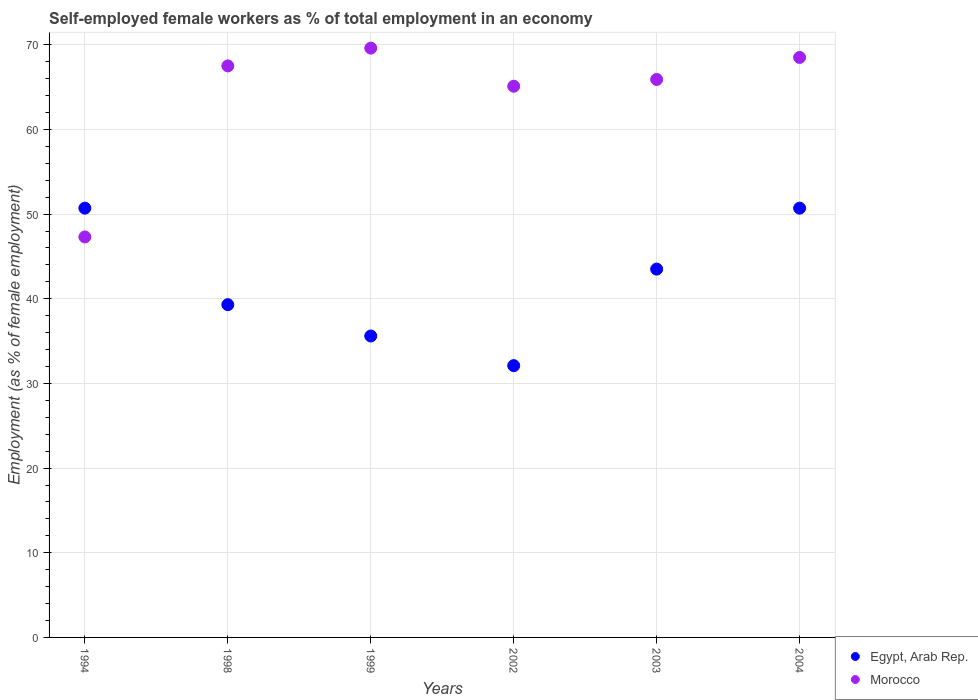How many different coloured dotlines are there?
Give a very brief answer. 2. What is the percentage of self-employed female workers in Morocco in 1999?
Give a very brief answer. 69.6. Across all years, what is the maximum percentage of self-employed female workers in Morocco?
Keep it short and to the point. 69.6. Across all years, what is the minimum percentage of self-employed female workers in Egypt, Arab Rep.?
Provide a succinct answer. 32.1. In which year was the percentage of self-employed female workers in Egypt, Arab Rep. maximum?
Your response must be concise. 1994. What is the total percentage of self-employed female workers in Morocco in the graph?
Provide a short and direct response. 383.9. What is the difference between the percentage of self-employed female workers in Egypt, Arab Rep. in 2002 and that in 2004?
Give a very brief answer. -18.6. What is the difference between the percentage of self-employed female workers in Egypt, Arab Rep. in 2004 and the percentage of self-employed female workers in Morocco in 1999?
Provide a short and direct response. -18.9. What is the average percentage of self-employed female workers in Egypt, Arab Rep. per year?
Offer a terse response. 41.98. In the year 2002, what is the difference between the percentage of self-employed female workers in Morocco and percentage of self-employed female workers in Egypt, Arab Rep.?
Provide a short and direct response. 33. What is the ratio of the percentage of self-employed female workers in Morocco in 1998 to that in 2004?
Your answer should be very brief. 0.99. Is the percentage of self-employed female workers in Egypt, Arab Rep. in 1994 less than that in 2003?
Your answer should be very brief. No. What is the difference between the highest and the second highest percentage of self-employed female workers in Egypt, Arab Rep.?
Give a very brief answer. 0. What is the difference between the highest and the lowest percentage of self-employed female workers in Morocco?
Provide a short and direct response. 22.3. How many dotlines are there?
Keep it short and to the point. 2. How many years are there in the graph?
Make the answer very short. 6. What is the difference between two consecutive major ticks on the Y-axis?
Give a very brief answer. 10. Are the values on the major ticks of Y-axis written in scientific E-notation?
Your answer should be compact. No. Where does the legend appear in the graph?
Offer a terse response. Bottom right. What is the title of the graph?
Your answer should be very brief. Self-employed female workers as % of total employment in an economy. Does "Grenada" appear as one of the legend labels in the graph?
Provide a short and direct response. No. What is the label or title of the Y-axis?
Offer a very short reply. Employment (as % of female employment). What is the Employment (as % of female employment) in Egypt, Arab Rep. in 1994?
Your answer should be compact. 50.7. What is the Employment (as % of female employment) of Morocco in 1994?
Provide a short and direct response. 47.3. What is the Employment (as % of female employment) of Egypt, Arab Rep. in 1998?
Provide a short and direct response. 39.3. What is the Employment (as % of female employment) of Morocco in 1998?
Provide a short and direct response. 67.5. What is the Employment (as % of female employment) in Egypt, Arab Rep. in 1999?
Give a very brief answer. 35.6. What is the Employment (as % of female employment) of Morocco in 1999?
Your answer should be very brief. 69.6. What is the Employment (as % of female employment) in Egypt, Arab Rep. in 2002?
Make the answer very short. 32.1. What is the Employment (as % of female employment) of Morocco in 2002?
Your answer should be compact. 65.1. What is the Employment (as % of female employment) of Egypt, Arab Rep. in 2003?
Offer a terse response. 43.5. What is the Employment (as % of female employment) in Morocco in 2003?
Make the answer very short. 65.9. What is the Employment (as % of female employment) of Egypt, Arab Rep. in 2004?
Give a very brief answer. 50.7. What is the Employment (as % of female employment) of Morocco in 2004?
Your answer should be compact. 68.5. Across all years, what is the maximum Employment (as % of female employment) in Egypt, Arab Rep.?
Give a very brief answer. 50.7. Across all years, what is the maximum Employment (as % of female employment) of Morocco?
Provide a succinct answer. 69.6. Across all years, what is the minimum Employment (as % of female employment) in Egypt, Arab Rep.?
Your answer should be compact. 32.1. Across all years, what is the minimum Employment (as % of female employment) of Morocco?
Offer a terse response. 47.3. What is the total Employment (as % of female employment) of Egypt, Arab Rep. in the graph?
Your answer should be compact. 251.9. What is the total Employment (as % of female employment) of Morocco in the graph?
Your answer should be compact. 383.9. What is the difference between the Employment (as % of female employment) of Egypt, Arab Rep. in 1994 and that in 1998?
Your answer should be compact. 11.4. What is the difference between the Employment (as % of female employment) of Morocco in 1994 and that in 1998?
Ensure brevity in your answer.  -20.2. What is the difference between the Employment (as % of female employment) in Egypt, Arab Rep. in 1994 and that in 1999?
Keep it short and to the point. 15.1. What is the difference between the Employment (as % of female employment) of Morocco in 1994 and that in 1999?
Provide a short and direct response. -22.3. What is the difference between the Employment (as % of female employment) of Morocco in 1994 and that in 2002?
Provide a succinct answer. -17.8. What is the difference between the Employment (as % of female employment) of Morocco in 1994 and that in 2003?
Your response must be concise. -18.6. What is the difference between the Employment (as % of female employment) of Egypt, Arab Rep. in 1994 and that in 2004?
Your response must be concise. 0. What is the difference between the Employment (as % of female employment) in Morocco in 1994 and that in 2004?
Provide a succinct answer. -21.2. What is the difference between the Employment (as % of female employment) in Egypt, Arab Rep. in 1998 and that in 1999?
Your answer should be very brief. 3.7. What is the difference between the Employment (as % of female employment) in Morocco in 1998 and that in 2002?
Your answer should be compact. 2.4. What is the difference between the Employment (as % of female employment) in Morocco in 1998 and that in 2003?
Make the answer very short. 1.6. What is the difference between the Employment (as % of female employment) in Egypt, Arab Rep. in 1999 and that in 2002?
Your answer should be very brief. 3.5. What is the difference between the Employment (as % of female employment) of Egypt, Arab Rep. in 1999 and that in 2004?
Offer a very short reply. -15.1. What is the difference between the Employment (as % of female employment) of Morocco in 1999 and that in 2004?
Give a very brief answer. 1.1. What is the difference between the Employment (as % of female employment) in Egypt, Arab Rep. in 2002 and that in 2003?
Your response must be concise. -11.4. What is the difference between the Employment (as % of female employment) in Morocco in 2002 and that in 2003?
Give a very brief answer. -0.8. What is the difference between the Employment (as % of female employment) in Egypt, Arab Rep. in 2002 and that in 2004?
Keep it short and to the point. -18.6. What is the difference between the Employment (as % of female employment) of Egypt, Arab Rep. in 1994 and the Employment (as % of female employment) of Morocco in 1998?
Ensure brevity in your answer.  -16.8. What is the difference between the Employment (as % of female employment) in Egypt, Arab Rep. in 1994 and the Employment (as % of female employment) in Morocco in 1999?
Provide a succinct answer. -18.9. What is the difference between the Employment (as % of female employment) of Egypt, Arab Rep. in 1994 and the Employment (as % of female employment) of Morocco in 2002?
Your answer should be very brief. -14.4. What is the difference between the Employment (as % of female employment) of Egypt, Arab Rep. in 1994 and the Employment (as % of female employment) of Morocco in 2003?
Your response must be concise. -15.2. What is the difference between the Employment (as % of female employment) of Egypt, Arab Rep. in 1994 and the Employment (as % of female employment) of Morocco in 2004?
Keep it short and to the point. -17.8. What is the difference between the Employment (as % of female employment) of Egypt, Arab Rep. in 1998 and the Employment (as % of female employment) of Morocco in 1999?
Provide a succinct answer. -30.3. What is the difference between the Employment (as % of female employment) in Egypt, Arab Rep. in 1998 and the Employment (as % of female employment) in Morocco in 2002?
Provide a succinct answer. -25.8. What is the difference between the Employment (as % of female employment) in Egypt, Arab Rep. in 1998 and the Employment (as % of female employment) in Morocco in 2003?
Make the answer very short. -26.6. What is the difference between the Employment (as % of female employment) in Egypt, Arab Rep. in 1998 and the Employment (as % of female employment) in Morocco in 2004?
Provide a short and direct response. -29.2. What is the difference between the Employment (as % of female employment) in Egypt, Arab Rep. in 1999 and the Employment (as % of female employment) in Morocco in 2002?
Provide a succinct answer. -29.5. What is the difference between the Employment (as % of female employment) of Egypt, Arab Rep. in 1999 and the Employment (as % of female employment) of Morocco in 2003?
Give a very brief answer. -30.3. What is the difference between the Employment (as % of female employment) of Egypt, Arab Rep. in 1999 and the Employment (as % of female employment) of Morocco in 2004?
Give a very brief answer. -32.9. What is the difference between the Employment (as % of female employment) of Egypt, Arab Rep. in 2002 and the Employment (as % of female employment) of Morocco in 2003?
Your response must be concise. -33.8. What is the difference between the Employment (as % of female employment) in Egypt, Arab Rep. in 2002 and the Employment (as % of female employment) in Morocco in 2004?
Give a very brief answer. -36.4. What is the difference between the Employment (as % of female employment) in Egypt, Arab Rep. in 2003 and the Employment (as % of female employment) in Morocco in 2004?
Your response must be concise. -25. What is the average Employment (as % of female employment) in Egypt, Arab Rep. per year?
Provide a succinct answer. 41.98. What is the average Employment (as % of female employment) of Morocco per year?
Offer a terse response. 63.98. In the year 1994, what is the difference between the Employment (as % of female employment) of Egypt, Arab Rep. and Employment (as % of female employment) of Morocco?
Provide a succinct answer. 3.4. In the year 1998, what is the difference between the Employment (as % of female employment) of Egypt, Arab Rep. and Employment (as % of female employment) of Morocco?
Ensure brevity in your answer.  -28.2. In the year 1999, what is the difference between the Employment (as % of female employment) of Egypt, Arab Rep. and Employment (as % of female employment) of Morocco?
Your answer should be very brief. -34. In the year 2002, what is the difference between the Employment (as % of female employment) of Egypt, Arab Rep. and Employment (as % of female employment) of Morocco?
Keep it short and to the point. -33. In the year 2003, what is the difference between the Employment (as % of female employment) in Egypt, Arab Rep. and Employment (as % of female employment) in Morocco?
Your answer should be compact. -22.4. In the year 2004, what is the difference between the Employment (as % of female employment) of Egypt, Arab Rep. and Employment (as % of female employment) of Morocco?
Offer a terse response. -17.8. What is the ratio of the Employment (as % of female employment) in Egypt, Arab Rep. in 1994 to that in 1998?
Your response must be concise. 1.29. What is the ratio of the Employment (as % of female employment) of Morocco in 1994 to that in 1998?
Ensure brevity in your answer.  0.7. What is the ratio of the Employment (as % of female employment) in Egypt, Arab Rep. in 1994 to that in 1999?
Make the answer very short. 1.42. What is the ratio of the Employment (as % of female employment) in Morocco in 1994 to that in 1999?
Provide a succinct answer. 0.68. What is the ratio of the Employment (as % of female employment) of Egypt, Arab Rep. in 1994 to that in 2002?
Your response must be concise. 1.58. What is the ratio of the Employment (as % of female employment) of Morocco in 1994 to that in 2002?
Provide a short and direct response. 0.73. What is the ratio of the Employment (as % of female employment) of Egypt, Arab Rep. in 1994 to that in 2003?
Offer a very short reply. 1.17. What is the ratio of the Employment (as % of female employment) of Morocco in 1994 to that in 2003?
Ensure brevity in your answer.  0.72. What is the ratio of the Employment (as % of female employment) in Morocco in 1994 to that in 2004?
Ensure brevity in your answer.  0.69. What is the ratio of the Employment (as % of female employment) of Egypt, Arab Rep. in 1998 to that in 1999?
Make the answer very short. 1.1. What is the ratio of the Employment (as % of female employment) in Morocco in 1998 to that in 1999?
Provide a short and direct response. 0.97. What is the ratio of the Employment (as % of female employment) of Egypt, Arab Rep. in 1998 to that in 2002?
Your answer should be compact. 1.22. What is the ratio of the Employment (as % of female employment) of Morocco in 1998 to that in 2002?
Give a very brief answer. 1.04. What is the ratio of the Employment (as % of female employment) in Egypt, Arab Rep. in 1998 to that in 2003?
Your response must be concise. 0.9. What is the ratio of the Employment (as % of female employment) of Morocco in 1998 to that in 2003?
Keep it short and to the point. 1.02. What is the ratio of the Employment (as % of female employment) of Egypt, Arab Rep. in 1998 to that in 2004?
Give a very brief answer. 0.78. What is the ratio of the Employment (as % of female employment) of Morocco in 1998 to that in 2004?
Offer a terse response. 0.99. What is the ratio of the Employment (as % of female employment) of Egypt, Arab Rep. in 1999 to that in 2002?
Make the answer very short. 1.11. What is the ratio of the Employment (as % of female employment) of Morocco in 1999 to that in 2002?
Make the answer very short. 1.07. What is the ratio of the Employment (as % of female employment) of Egypt, Arab Rep. in 1999 to that in 2003?
Offer a terse response. 0.82. What is the ratio of the Employment (as % of female employment) in Morocco in 1999 to that in 2003?
Your answer should be very brief. 1.06. What is the ratio of the Employment (as % of female employment) of Egypt, Arab Rep. in 1999 to that in 2004?
Your response must be concise. 0.7. What is the ratio of the Employment (as % of female employment) in Morocco in 1999 to that in 2004?
Your response must be concise. 1.02. What is the ratio of the Employment (as % of female employment) of Egypt, Arab Rep. in 2002 to that in 2003?
Offer a terse response. 0.74. What is the ratio of the Employment (as % of female employment) in Morocco in 2002 to that in 2003?
Offer a very short reply. 0.99. What is the ratio of the Employment (as % of female employment) in Egypt, Arab Rep. in 2002 to that in 2004?
Provide a succinct answer. 0.63. What is the ratio of the Employment (as % of female employment) of Morocco in 2002 to that in 2004?
Your answer should be very brief. 0.95. What is the ratio of the Employment (as % of female employment) in Egypt, Arab Rep. in 2003 to that in 2004?
Your answer should be very brief. 0.86. What is the ratio of the Employment (as % of female employment) of Morocco in 2003 to that in 2004?
Offer a terse response. 0.96. What is the difference between the highest and the second highest Employment (as % of female employment) of Egypt, Arab Rep.?
Ensure brevity in your answer.  0. What is the difference between the highest and the second highest Employment (as % of female employment) of Morocco?
Provide a short and direct response. 1.1. What is the difference between the highest and the lowest Employment (as % of female employment) in Egypt, Arab Rep.?
Your answer should be very brief. 18.6. What is the difference between the highest and the lowest Employment (as % of female employment) in Morocco?
Provide a short and direct response. 22.3. 